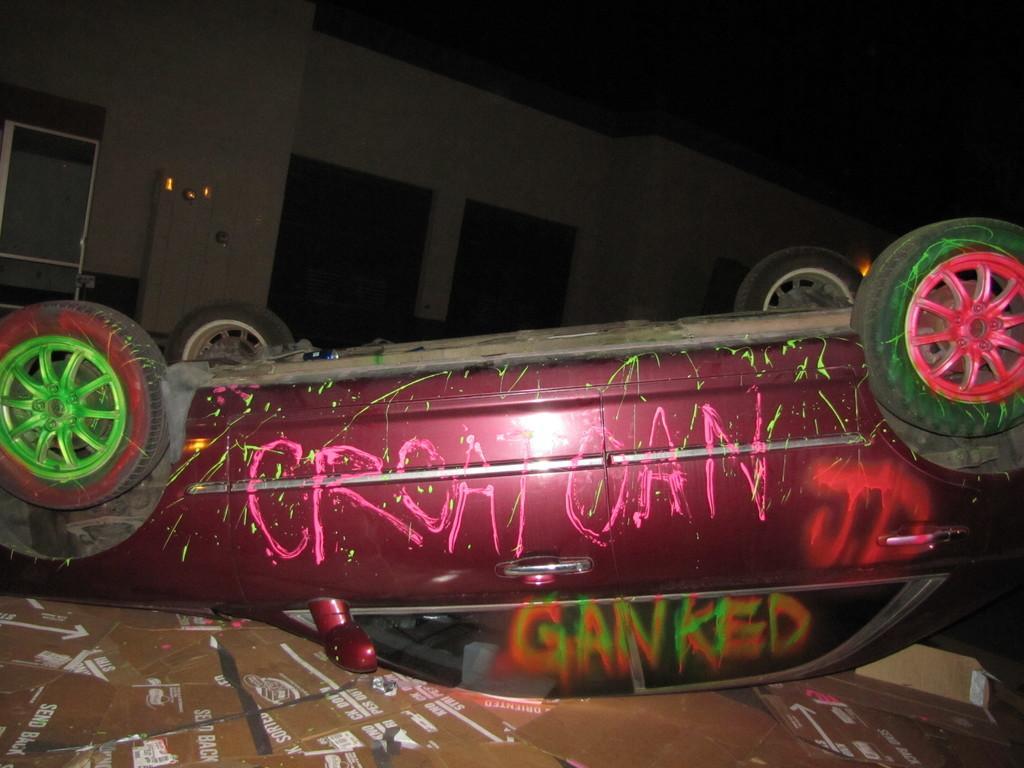In one or two sentences, can you explain what this image depicts? In this image there is a vehicle, cardboard, wall and objects. Something is written on the vehicle and cardboards. 